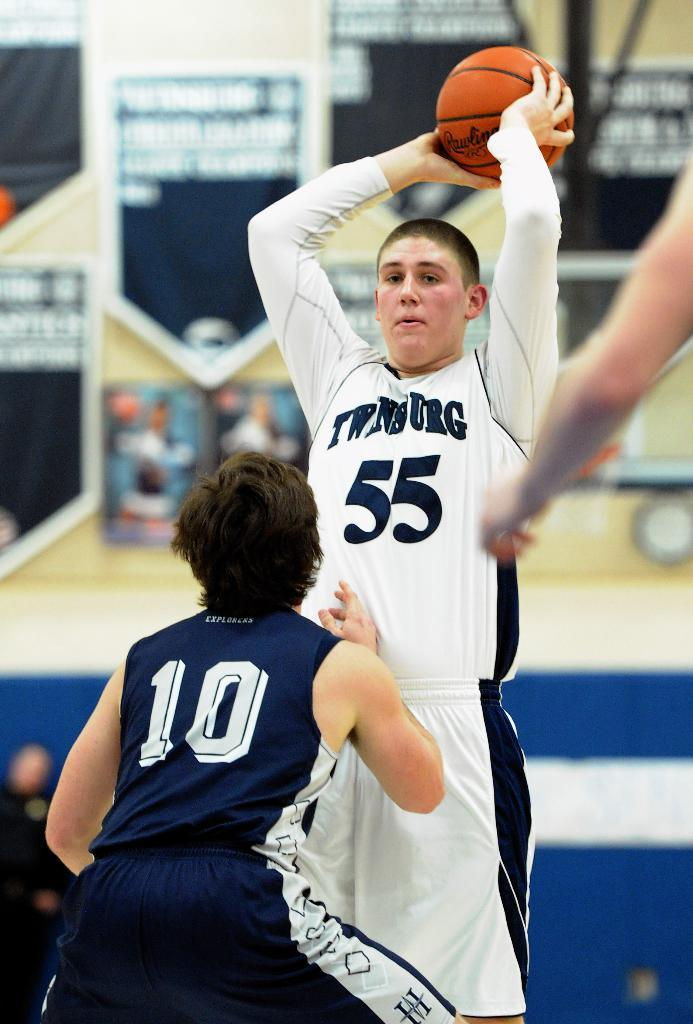Provide a one-sentence caption for the provided image. A boy wearing a number 55 jersey holds a basketball and stands above a person wearing a jersey with the number 10. 